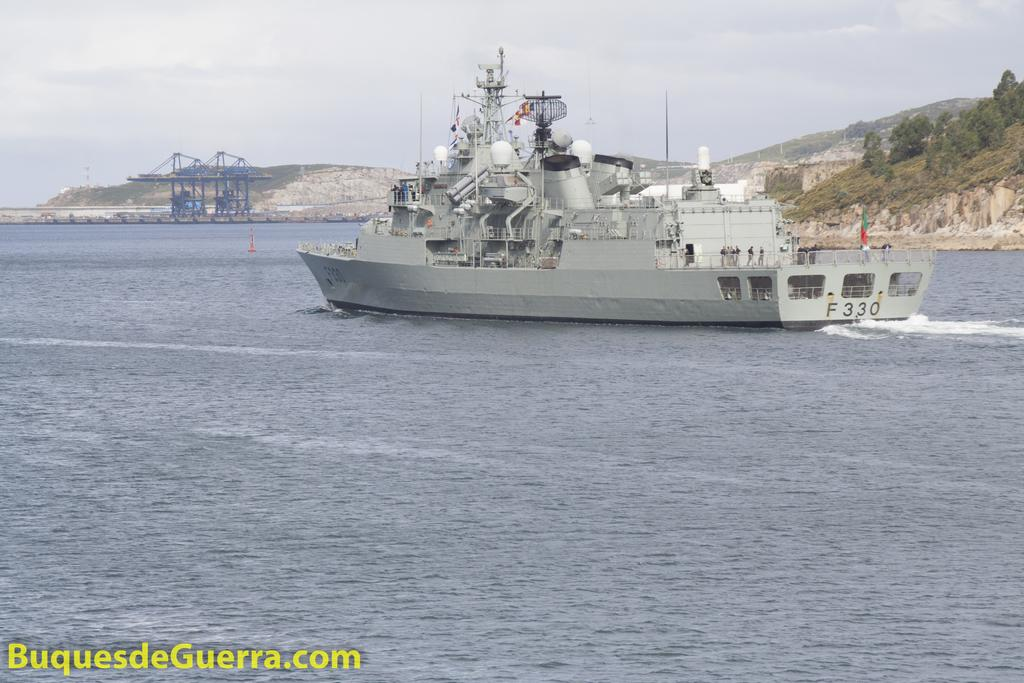Provide a one-sentence caption for the provided image. A boat that has F330 on the back side. 